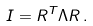Convert formula to latex. <formula><loc_0><loc_0><loc_500><loc_500>I = R ^ { T } \Lambda R \, .</formula> 